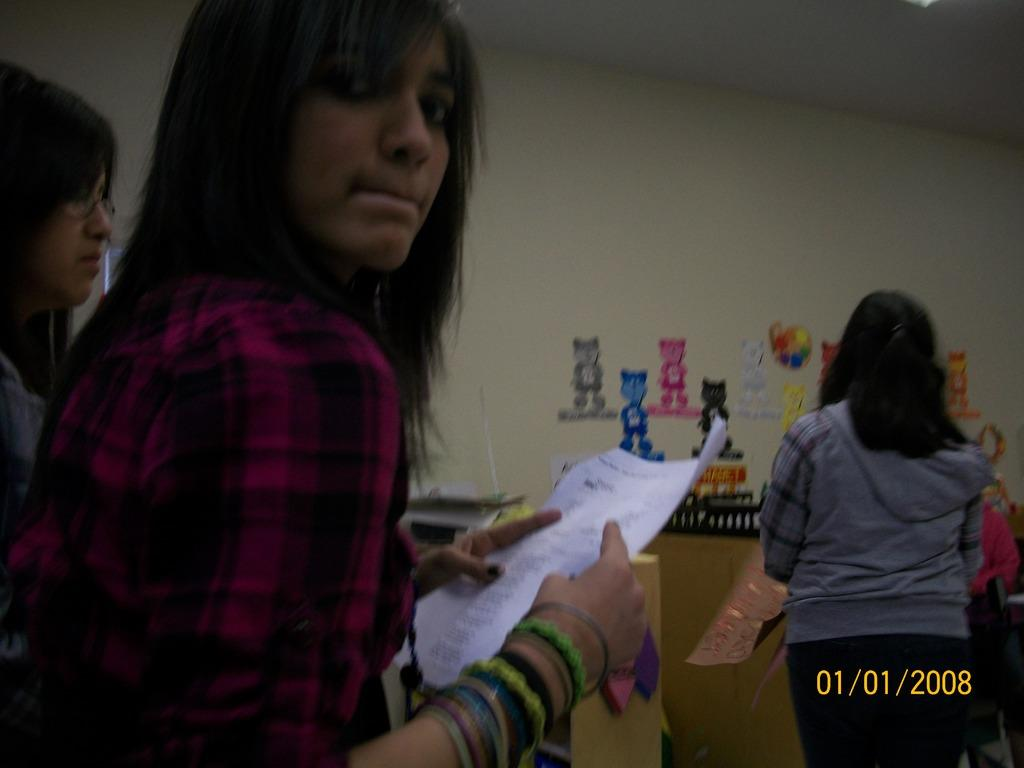Provide a one-sentence caption for the provided image. The line only contained three people on 01/01/2008. 